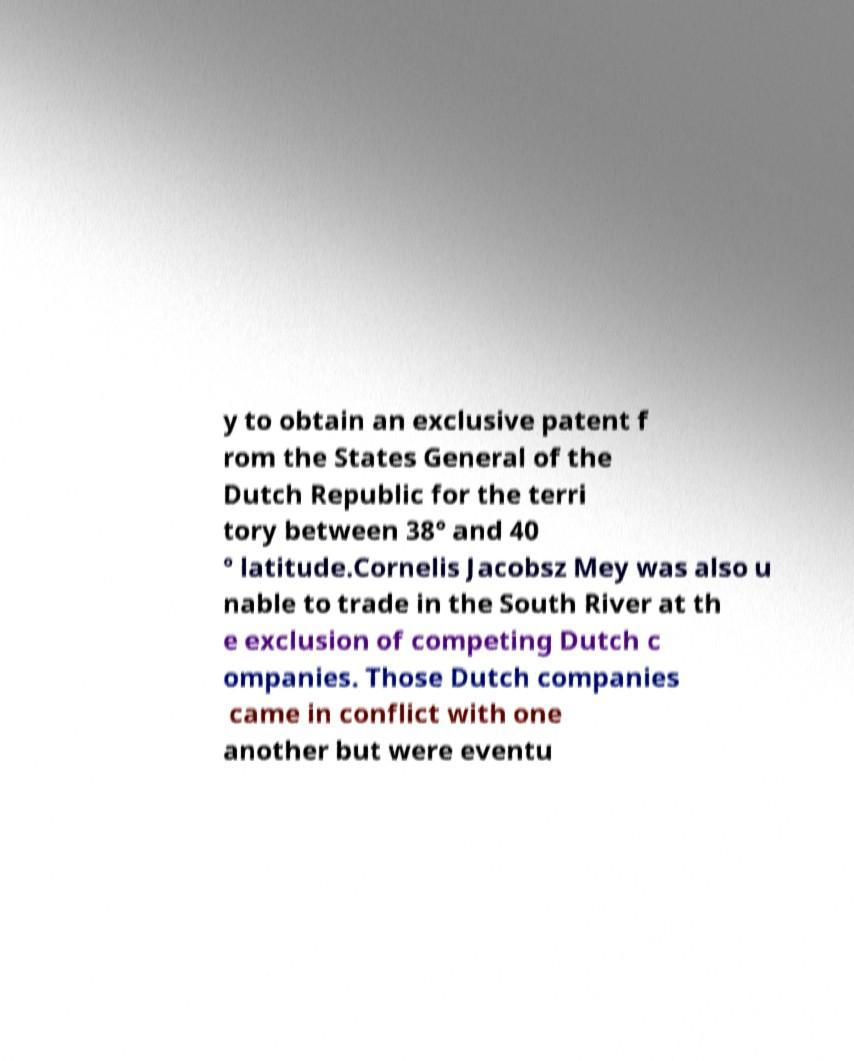For documentation purposes, I need the text within this image transcribed. Could you provide that? y to obtain an exclusive patent f rom the States General of the Dutch Republic for the terri tory between 38° and 40 ° latitude.Cornelis Jacobsz Mey was also u nable to trade in the South River at th e exclusion of competing Dutch c ompanies. Those Dutch companies came in conflict with one another but were eventu 